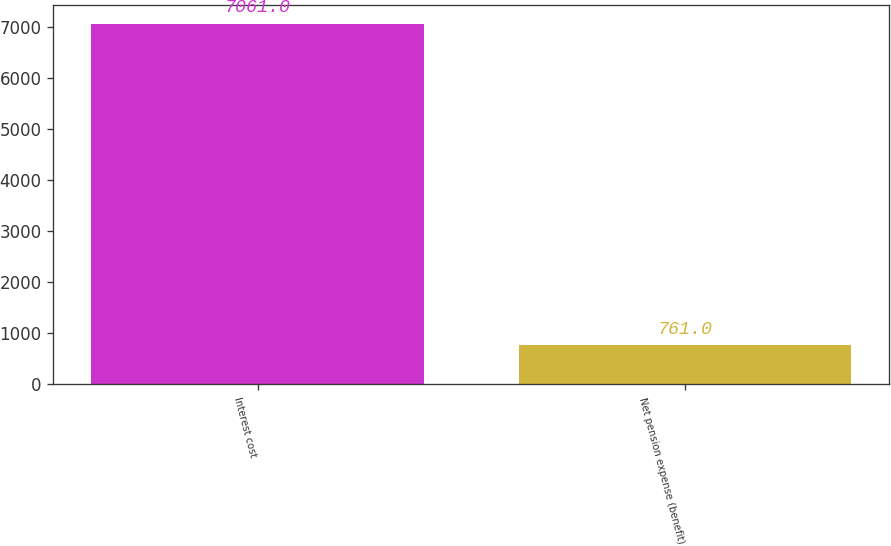<chart> <loc_0><loc_0><loc_500><loc_500><bar_chart><fcel>Interest cost<fcel>Net pension expense (benefit)<nl><fcel>7061<fcel>761<nl></chart> 